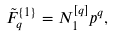<formula> <loc_0><loc_0><loc_500><loc_500>\tilde { F } _ { q } ^ { \{ 1 \} } = N ^ { [ q ] } _ { 1 } p ^ { q } ,</formula> 